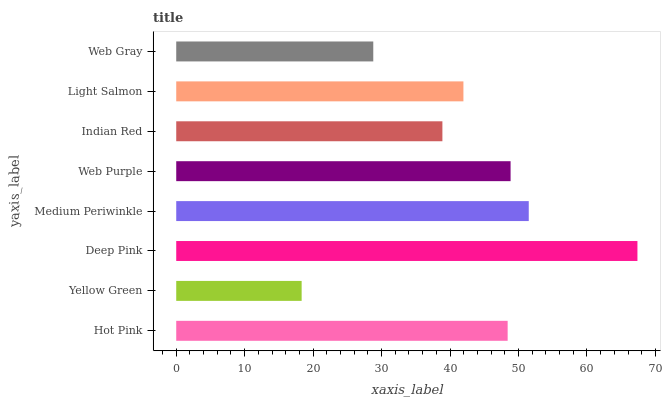Is Yellow Green the minimum?
Answer yes or no. Yes. Is Deep Pink the maximum?
Answer yes or no. Yes. Is Deep Pink the minimum?
Answer yes or no. No. Is Yellow Green the maximum?
Answer yes or no. No. Is Deep Pink greater than Yellow Green?
Answer yes or no. Yes. Is Yellow Green less than Deep Pink?
Answer yes or no. Yes. Is Yellow Green greater than Deep Pink?
Answer yes or no. No. Is Deep Pink less than Yellow Green?
Answer yes or no. No. Is Hot Pink the high median?
Answer yes or no. Yes. Is Light Salmon the low median?
Answer yes or no. Yes. Is Deep Pink the high median?
Answer yes or no. No. Is Deep Pink the low median?
Answer yes or no. No. 